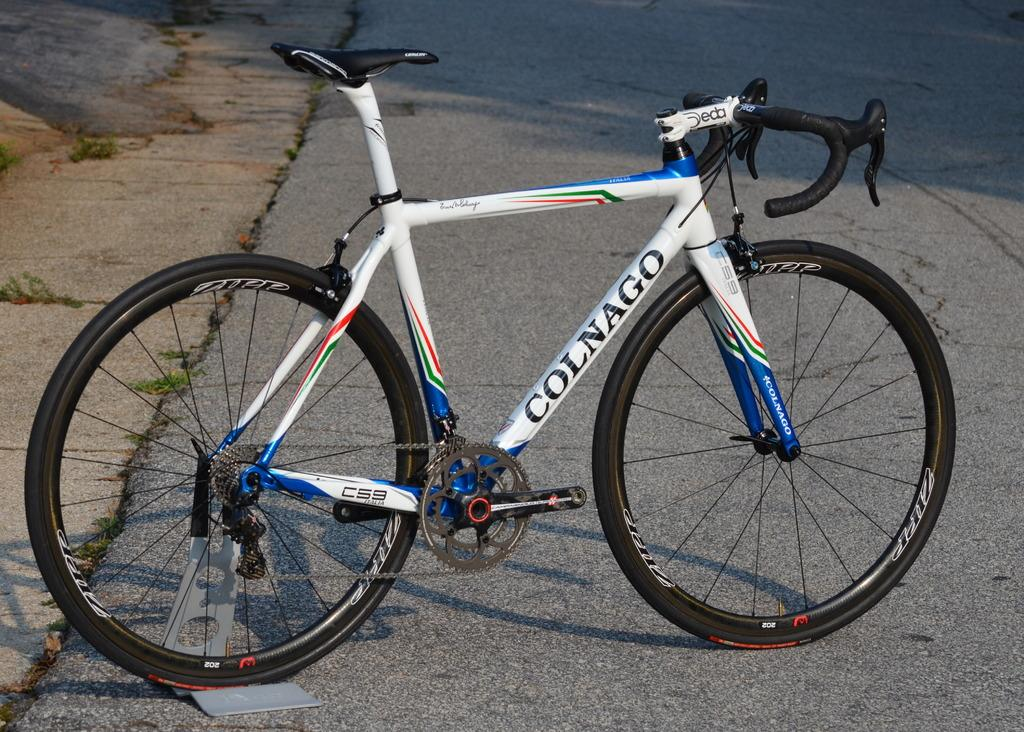What is the main subject of the image? The main subject of the image is a bicycle. Where is the bicycle located in the image? The bicycle is in the center of the image. What is the setting of the image? The bicycle is on the road. What type of meal is being prepared on the bicycle in the image? There is no meal being prepared on the bicycle in the image; it is simply a bicycle on the road. 